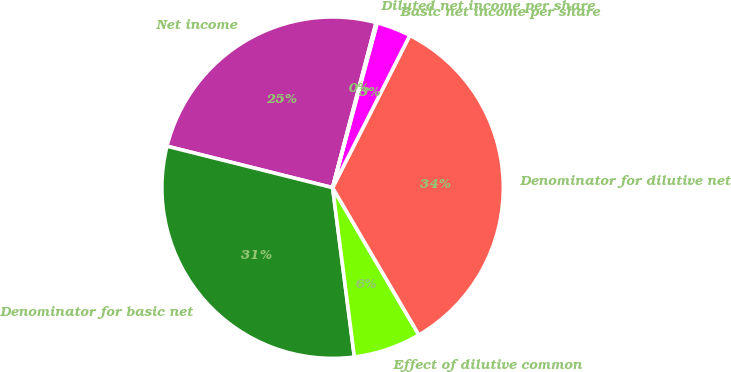<chart> <loc_0><loc_0><loc_500><loc_500><pie_chart><fcel>Net income<fcel>Denominator for basic net<fcel>Effect of dilutive common<fcel>Denominator for dilutive net<fcel>Basic net income per share<fcel>Diluted net income per share<nl><fcel>25.19%<fcel>30.94%<fcel>6.4%<fcel>34.09%<fcel>3.26%<fcel>0.11%<nl></chart> 